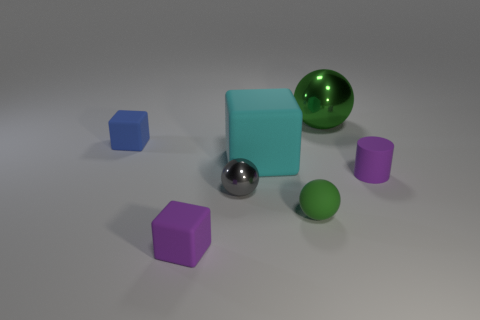Add 2 small blue rubber spheres. How many objects exist? 9 Subtract all blocks. How many objects are left? 4 Add 6 small green rubber things. How many small green rubber things exist? 7 Subtract 0 brown cylinders. How many objects are left? 7 Subtract all small blue matte things. Subtract all large objects. How many objects are left? 4 Add 4 big green metallic things. How many big green metallic things are left? 5 